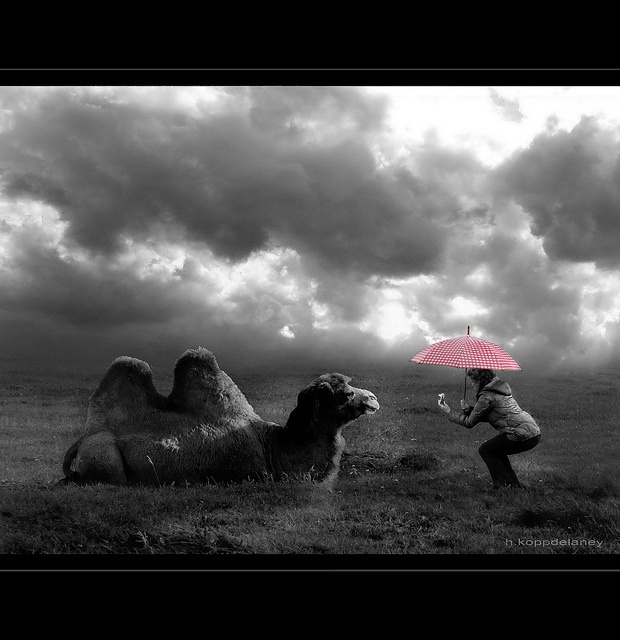Describe the objects in this image and their specific colors. I can see people in black, gray, darkgray, and lightgray tones and umbrella in black, lightpink, lightgray, brown, and darkgray tones in this image. 